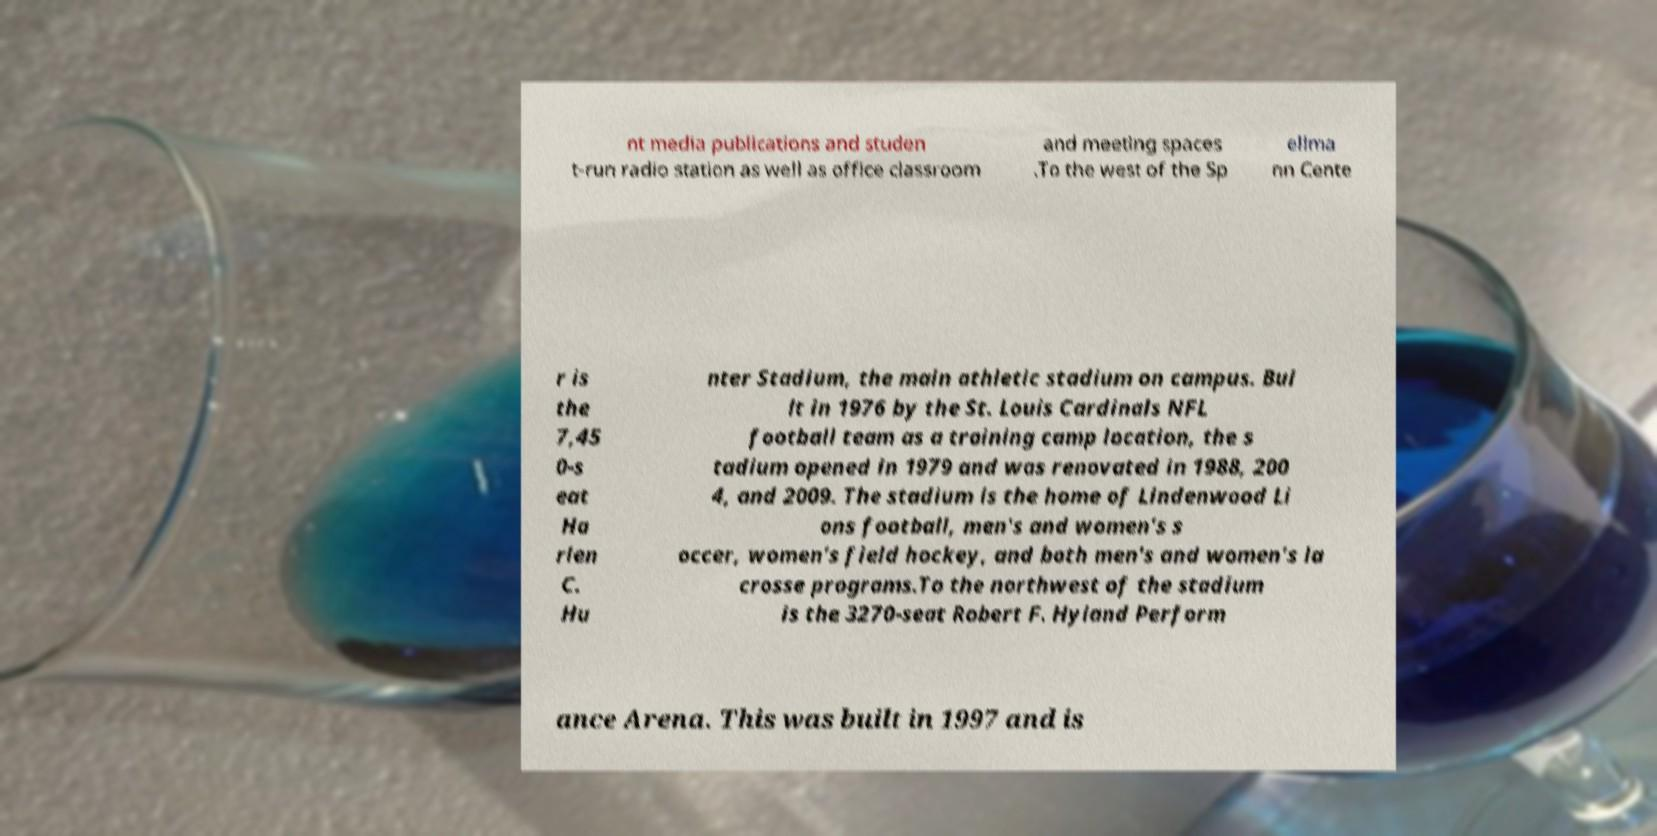Please read and relay the text visible in this image. What does it say? nt media publications and studen t-run radio station as well as office classroom and meeting spaces .To the west of the Sp ellma nn Cente r is the 7,45 0-s eat Ha rlen C. Hu nter Stadium, the main athletic stadium on campus. Bui lt in 1976 by the St. Louis Cardinals NFL football team as a training camp location, the s tadium opened in 1979 and was renovated in 1988, 200 4, and 2009. The stadium is the home of Lindenwood Li ons football, men's and women's s occer, women's field hockey, and both men's and women's la crosse programs.To the northwest of the stadium is the 3270-seat Robert F. Hyland Perform ance Arena. This was built in 1997 and is 